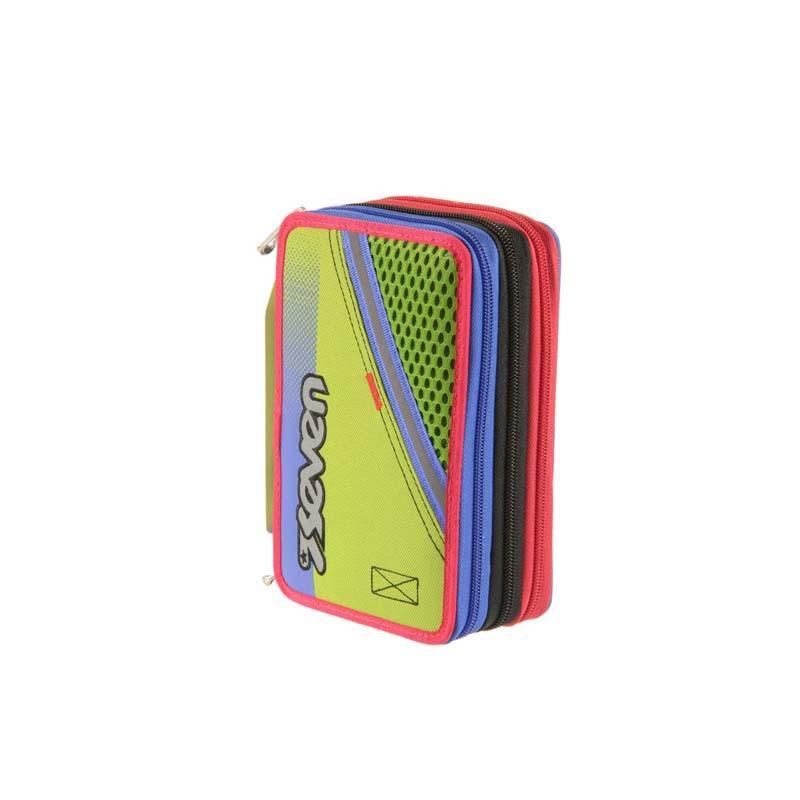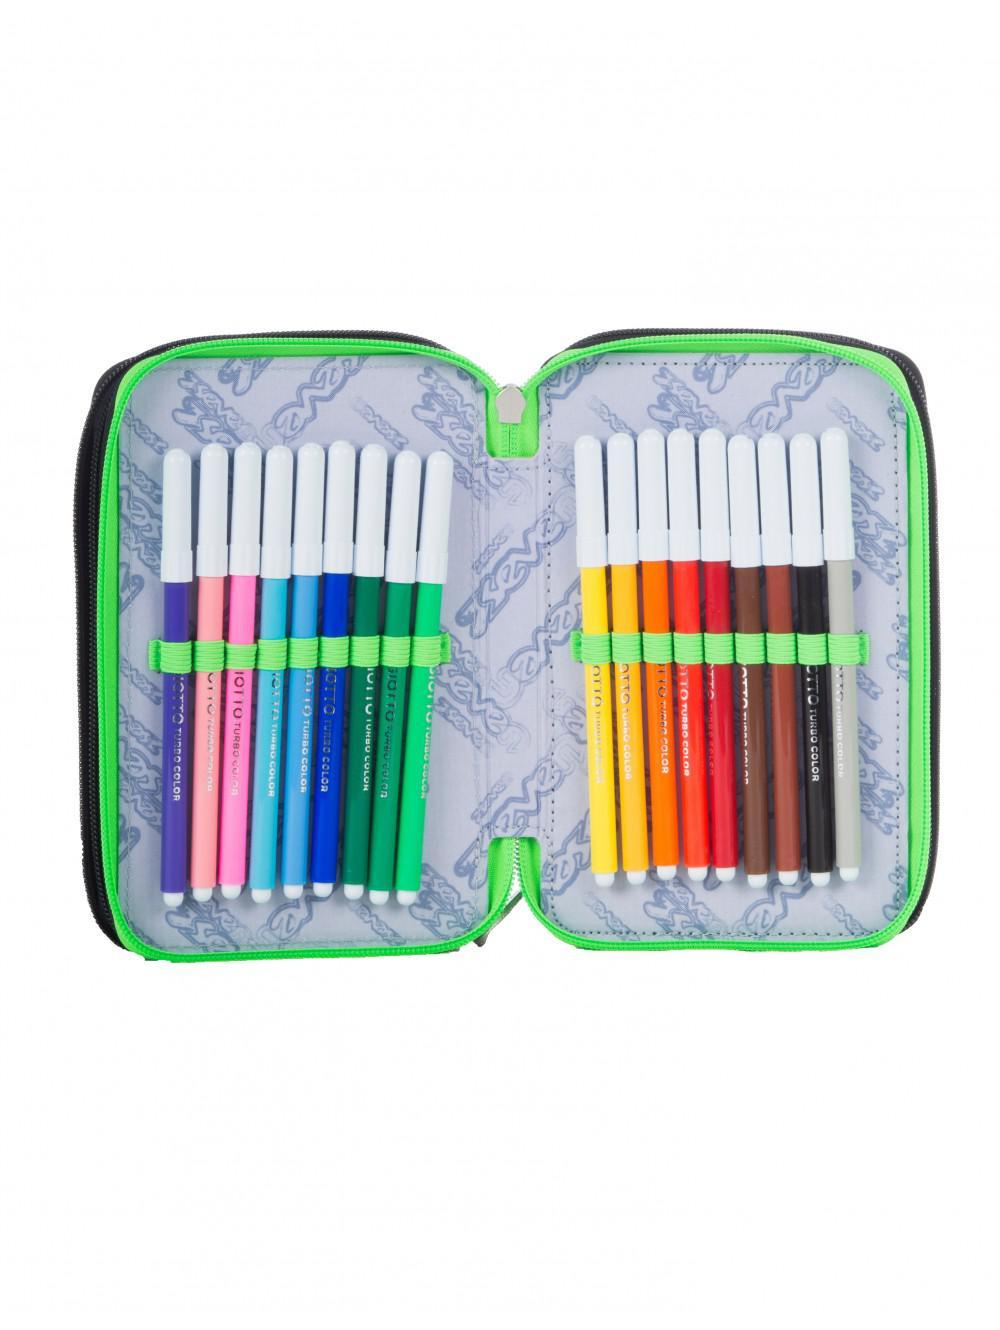The first image is the image on the left, the second image is the image on the right. Evaluate the accuracy of this statement regarding the images: "At least one pencil case has a pink inner lining.". Is it true? Answer yes or no. No. The first image is the image on the left, the second image is the image on the right. For the images shown, is this caption "One image shows a pencil case with a pink interior displayed so its multiple inner compartments fan out." true? Answer yes or no. No. 